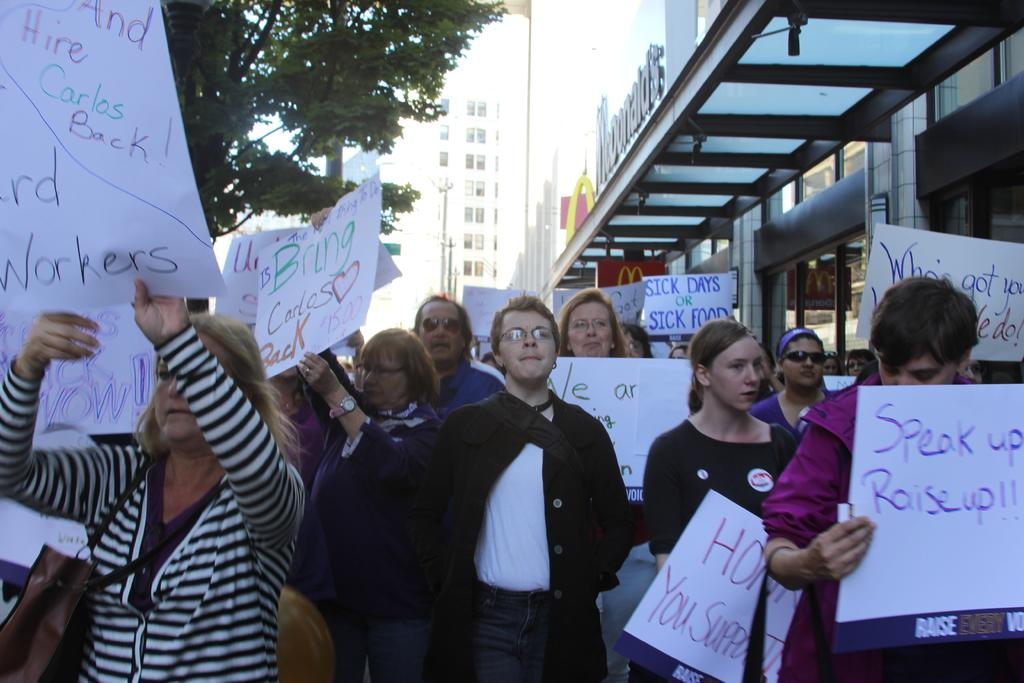What is happening with the group of people in the image? The people in the image are standing and holding papers. What can be seen on the papers they are holding? There is text written on all the papers. What type of structures are visible in the image? There are buildings in the image. What type of vegetation is present in the image? There is a tree in the image. What type of celery is growing near the tree in the image? There is no celery present in the image; it only features a tree and a group of people holding papers. 